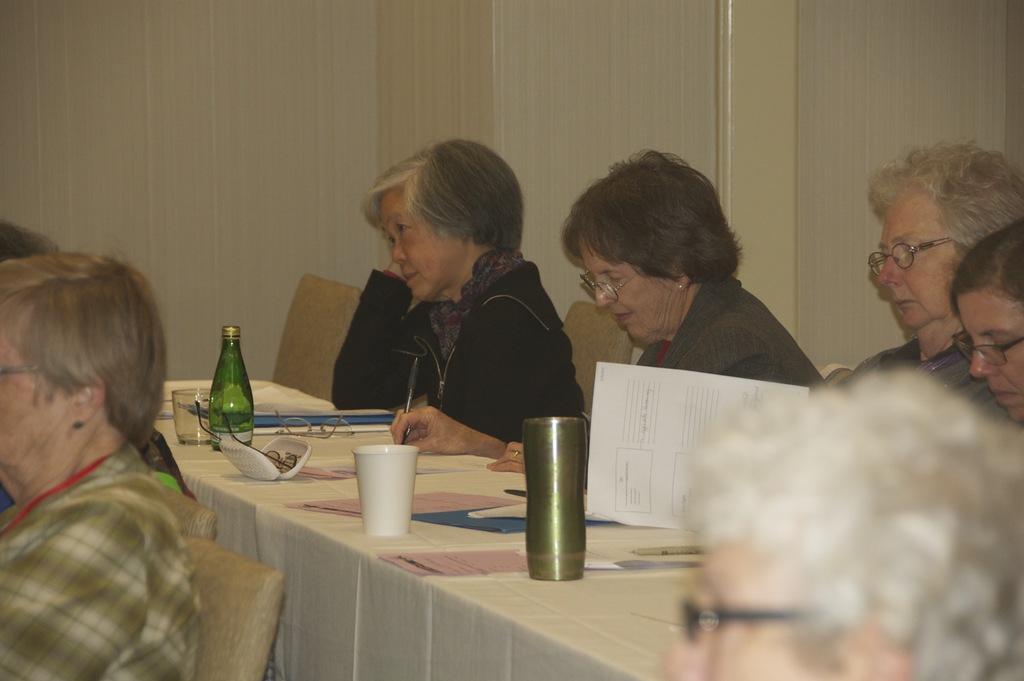In one or two sentences, can you explain what this image depicts? There are group of women sitting in chairs and there is a table in front of them, The table consists of paper,spectacles,mug and bottle and there are few people in front of them. 